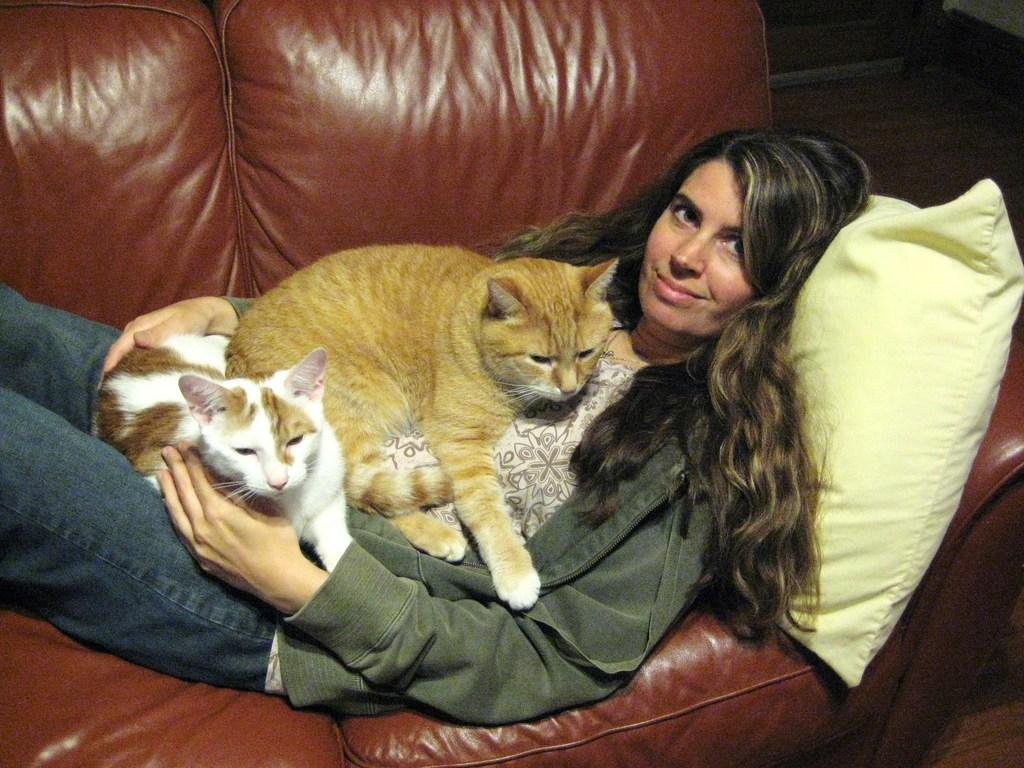Who is the main subject in the image? There is a lady in the image. What is the lady doing in the image? The lady is lying on a sofa. Where is the lady positioned in the image? The lady is at the center of the image. What other animals are present in the image? There are two cats in the image. How are the cats interacting with the lady? The cats are on the lady. What type of hand can be seen holding the tiger in the image? There is no tiger or hand present in the image. Is there a girl in the image? The provided facts do not mention a girl, only a lady. 